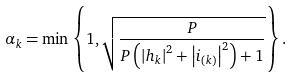<formula> <loc_0><loc_0><loc_500><loc_500>\alpha _ { k } = \min \left \{ 1 , \sqrt { \frac { P } { P \left ( \left | h _ { k } \right | ^ { 2 } + \left | i _ { ( k ) } \right | ^ { 2 } \right ) + 1 } } \right \} .</formula> 